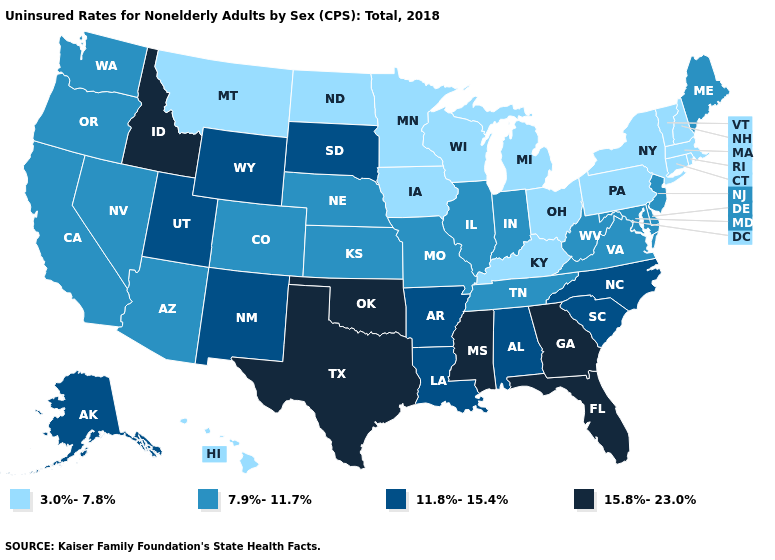Does Massachusetts have a lower value than New Hampshire?
Answer briefly. No. Does Wyoming have a lower value than New Jersey?
Write a very short answer. No. Name the states that have a value in the range 15.8%-23.0%?
Be succinct. Florida, Georgia, Idaho, Mississippi, Oklahoma, Texas. Which states have the highest value in the USA?
Quick response, please. Florida, Georgia, Idaho, Mississippi, Oklahoma, Texas. Does Maryland have a higher value than Pennsylvania?
Write a very short answer. Yes. Does the first symbol in the legend represent the smallest category?
Concise answer only. Yes. What is the value of New Jersey?
Give a very brief answer. 7.9%-11.7%. Which states have the lowest value in the Northeast?
Give a very brief answer. Connecticut, Massachusetts, New Hampshire, New York, Pennsylvania, Rhode Island, Vermont. Name the states that have a value in the range 3.0%-7.8%?
Be succinct. Connecticut, Hawaii, Iowa, Kentucky, Massachusetts, Michigan, Minnesota, Montana, New Hampshire, New York, North Dakota, Ohio, Pennsylvania, Rhode Island, Vermont, Wisconsin. Name the states that have a value in the range 11.8%-15.4%?
Short answer required. Alabama, Alaska, Arkansas, Louisiana, New Mexico, North Carolina, South Carolina, South Dakota, Utah, Wyoming. What is the value of Kansas?
Write a very short answer. 7.9%-11.7%. What is the highest value in the USA?
Write a very short answer. 15.8%-23.0%. What is the highest value in the USA?
Give a very brief answer. 15.8%-23.0%. 